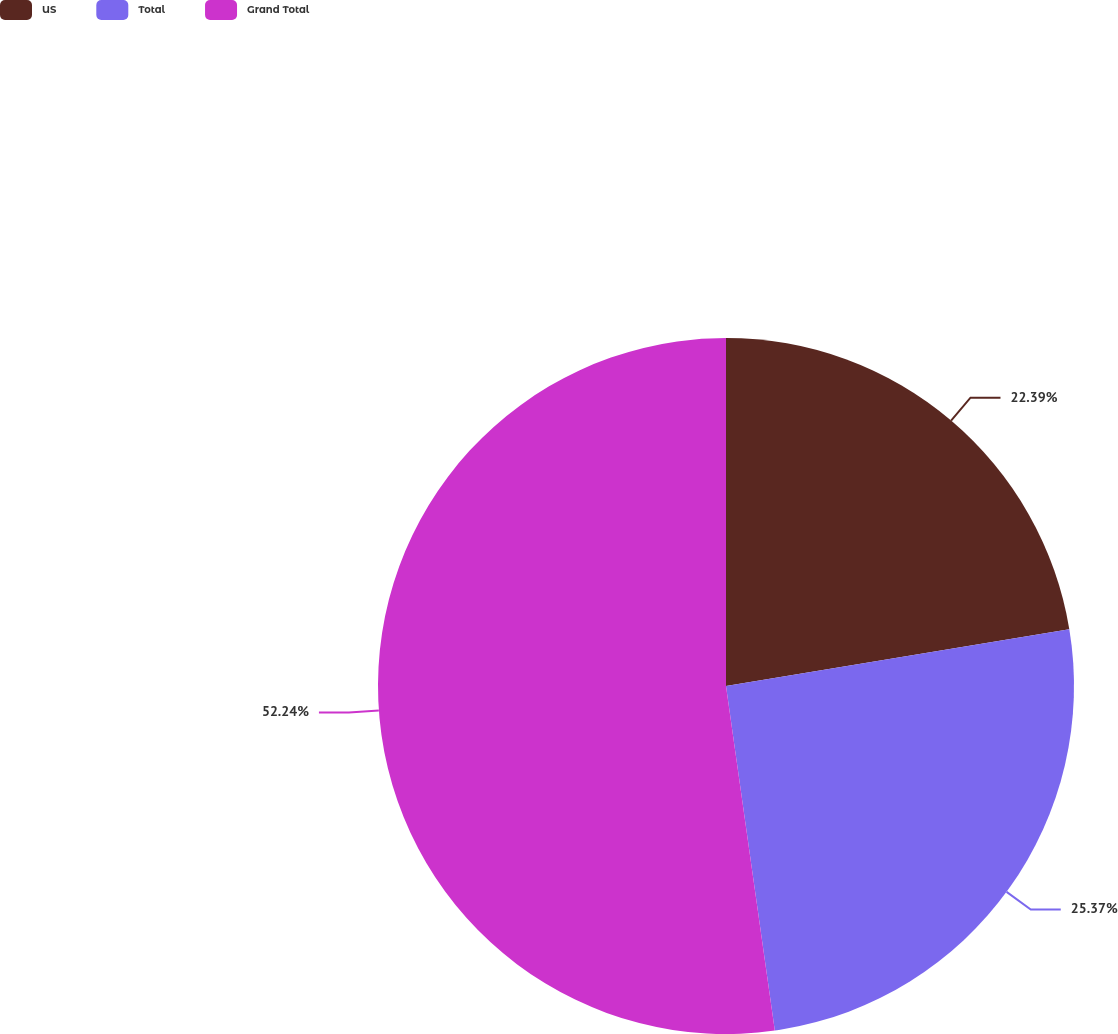Convert chart. <chart><loc_0><loc_0><loc_500><loc_500><pie_chart><fcel>US<fcel>Total<fcel>Grand Total<nl><fcel>22.39%<fcel>25.37%<fcel>52.24%<nl></chart> 